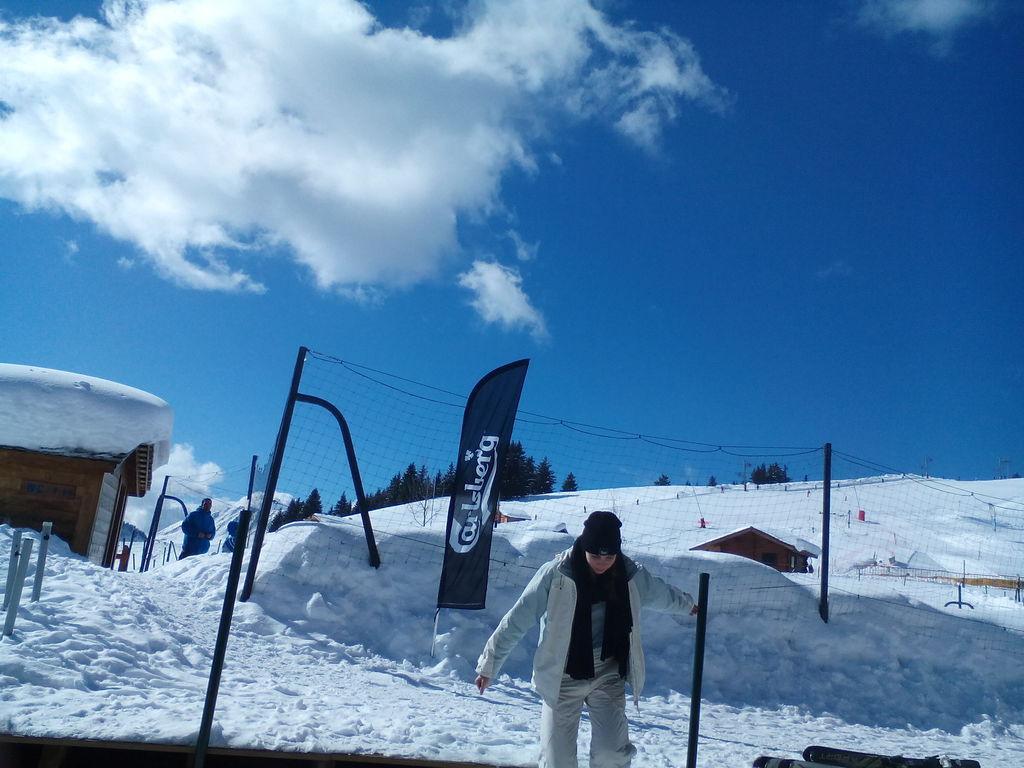Please provide a concise description of this image. In this image we can see a person wearing a coat is standing on ground. To the left side of the image we can see a person wearing a blue dress and a building. In the background, we can see a fence, group of poles and cloudy sky. 